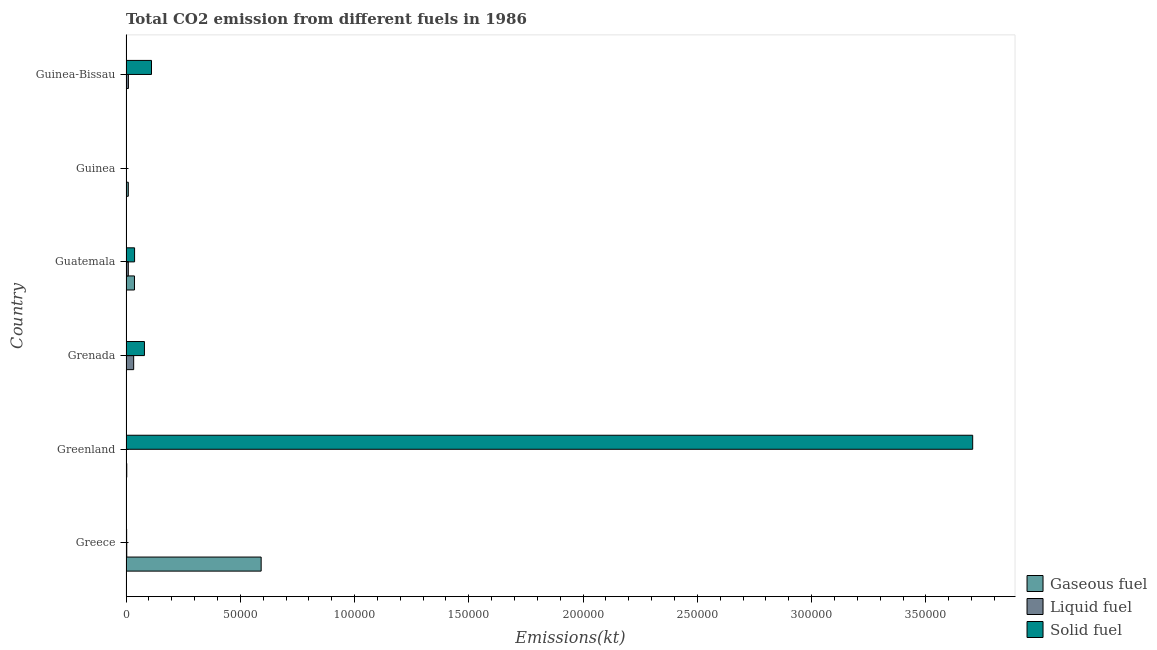How many different coloured bars are there?
Keep it short and to the point. 3. How many bars are there on the 3rd tick from the top?
Make the answer very short. 3. In how many cases, is the number of bars for a given country not equal to the number of legend labels?
Provide a succinct answer. 0. What is the amount of co2 emissions from liquid fuel in Guinea-Bissau?
Make the answer very short. 1045.1. Across all countries, what is the maximum amount of co2 emissions from liquid fuel?
Your answer should be very brief. 3351.64. Across all countries, what is the minimum amount of co2 emissions from gaseous fuel?
Your answer should be compact. 66.01. In which country was the amount of co2 emissions from solid fuel minimum?
Your answer should be compact. Guinea. What is the total amount of co2 emissions from solid fuel in the graph?
Make the answer very short. 3.94e+05. What is the difference between the amount of co2 emissions from liquid fuel in Greenland and that in Guinea-Bissau?
Ensure brevity in your answer.  -979.09. What is the difference between the amount of co2 emissions from liquid fuel in Guatemala and the amount of co2 emissions from gaseous fuel in Guinea-Bissau?
Provide a succinct answer. 814.07. What is the average amount of co2 emissions from liquid fuel per country?
Offer a terse response. 994.98. What is the difference between the amount of co2 emissions from liquid fuel and amount of co2 emissions from gaseous fuel in Greenland?
Offer a very short reply. -260.36. In how many countries, is the amount of co2 emissions from gaseous fuel greater than 60000 kt?
Offer a very short reply. 0. What is the ratio of the amount of co2 emissions from liquid fuel in Grenada to that in Guinea?
Offer a very short reply. 18.28. Is the amount of co2 emissions from gaseous fuel in Greece less than that in Guatemala?
Provide a succinct answer. No. Is the difference between the amount of co2 emissions from solid fuel in Greece and Guinea greater than the difference between the amount of co2 emissions from liquid fuel in Greece and Guinea?
Ensure brevity in your answer.  Yes. What is the difference between the highest and the second highest amount of co2 emissions from liquid fuel?
Offer a very short reply. 2306.54. What is the difference between the highest and the lowest amount of co2 emissions from liquid fuel?
Provide a succinct answer. 3285.63. In how many countries, is the amount of co2 emissions from solid fuel greater than the average amount of co2 emissions from solid fuel taken over all countries?
Your answer should be compact. 1. What does the 1st bar from the top in Greenland represents?
Provide a short and direct response. Solid fuel. What does the 3rd bar from the bottom in Guinea-Bissau represents?
Your answer should be compact. Solid fuel. How many bars are there?
Make the answer very short. 18. Are all the bars in the graph horizontal?
Offer a terse response. Yes. How many countries are there in the graph?
Give a very brief answer. 6. What is the difference between two consecutive major ticks on the X-axis?
Your answer should be compact. 5.00e+04. Where does the legend appear in the graph?
Offer a terse response. Bottom right. What is the title of the graph?
Keep it short and to the point. Total CO2 emission from different fuels in 1986. Does "Ages 60+" appear as one of the legend labels in the graph?
Provide a short and direct response. No. What is the label or title of the X-axis?
Your answer should be very brief. Emissions(kt). What is the label or title of the Y-axis?
Ensure brevity in your answer.  Country. What is the Emissions(kt) of Gaseous fuel in Greece?
Give a very brief answer. 5.91e+04. What is the Emissions(kt) of Liquid fuel in Greece?
Offer a very short reply. 326.36. What is the Emissions(kt) in Solid fuel in Greece?
Provide a succinct answer. 275.02. What is the Emissions(kt) in Gaseous fuel in Greenland?
Your answer should be very brief. 326.36. What is the Emissions(kt) of Liquid fuel in Greenland?
Offer a very short reply. 66.01. What is the Emissions(kt) in Solid fuel in Greenland?
Provide a succinct answer. 3.70e+05. What is the Emissions(kt) of Gaseous fuel in Grenada?
Make the answer very short. 66.01. What is the Emissions(kt) in Liquid fuel in Grenada?
Provide a succinct answer. 3351.64. What is the Emissions(kt) in Solid fuel in Grenada?
Make the answer very short. 8063.73. What is the Emissions(kt) in Gaseous fuel in Guatemala?
Your answer should be compact. 3700. What is the Emissions(kt) of Liquid fuel in Guatemala?
Your answer should be very brief. 997.42. What is the Emissions(kt) of Solid fuel in Guatemala?
Your response must be concise. 3747.67. What is the Emissions(kt) of Gaseous fuel in Guinea?
Provide a short and direct response. 997.42. What is the Emissions(kt) of Liquid fuel in Guinea?
Give a very brief answer. 183.35. What is the Emissions(kt) of Solid fuel in Guinea?
Make the answer very short. 3.67. What is the Emissions(kt) of Gaseous fuel in Guinea-Bissau?
Keep it short and to the point. 183.35. What is the Emissions(kt) in Liquid fuel in Guinea-Bissau?
Make the answer very short. 1045.1. What is the Emissions(kt) of Solid fuel in Guinea-Bissau?
Keep it short and to the point. 1.12e+04. Across all countries, what is the maximum Emissions(kt) in Gaseous fuel?
Provide a short and direct response. 5.91e+04. Across all countries, what is the maximum Emissions(kt) of Liquid fuel?
Your answer should be compact. 3351.64. Across all countries, what is the maximum Emissions(kt) in Solid fuel?
Offer a terse response. 3.70e+05. Across all countries, what is the minimum Emissions(kt) in Gaseous fuel?
Offer a terse response. 66.01. Across all countries, what is the minimum Emissions(kt) of Liquid fuel?
Offer a terse response. 66.01. Across all countries, what is the minimum Emissions(kt) of Solid fuel?
Your answer should be compact. 3.67. What is the total Emissions(kt) in Gaseous fuel in the graph?
Provide a succinct answer. 6.44e+04. What is the total Emissions(kt) of Liquid fuel in the graph?
Your response must be concise. 5969.88. What is the total Emissions(kt) in Solid fuel in the graph?
Ensure brevity in your answer.  3.94e+05. What is the difference between the Emissions(kt) of Gaseous fuel in Greece and that in Greenland?
Your answer should be very brief. 5.88e+04. What is the difference between the Emissions(kt) of Liquid fuel in Greece and that in Greenland?
Give a very brief answer. 260.36. What is the difference between the Emissions(kt) in Solid fuel in Greece and that in Greenland?
Give a very brief answer. -3.70e+05. What is the difference between the Emissions(kt) of Gaseous fuel in Greece and that in Grenada?
Give a very brief answer. 5.91e+04. What is the difference between the Emissions(kt) in Liquid fuel in Greece and that in Grenada?
Your answer should be compact. -3025.28. What is the difference between the Emissions(kt) of Solid fuel in Greece and that in Grenada?
Keep it short and to the point. -7788.71. What is the difference between the Emissions(kt) of Gaseous fuel in Greece and that in Guatemala?
Your answer should be compact. 5.54e+04. What is the difference between the Emissions(kt) in Liquid fuel in Greece and that in Guatemala?
Your answer should be very brief. -671.06. What is the difference between the Emissions(kt) in Solid fuel in Greece and that in Guatemala?
Your response must be concise. -3472.65. What is the difference between the Emissions(kt) of Gaseous fuel in Greece and that in Guinea?
Ensure brevity in your answer.  5.81e+04. What is the difference between the Emissions(kt) in Liquid fuel in Greece and that in Guinea?
Give a very brief answer. 143.01. What is the difference between the Emissions(kt) in Solid fuel in Greece and that in Guinea?
Ensure brevity in your answer.  271.36. What is the difference between the Emissions(kt) of Gaseous fuel in Greece and that in Guinea-Bissau?
Offer a very short reply. 5.89e+04. What is the difference between the Emissions(kt) in Liquid fuel in Greece and that in Guinea-Bissau?
Your answer should be very brief. -718.73. What is the difference between the Emissions(kt) of Solid fuel in Greece and that in Guinea-Bissau?
Your answer should be compact. -1.09e+04. What is the difference between the Emissions(kt) in Gaseous fuel in Greenland and that in Grenada?
Your answer should be compact. 260.36. What is the difference between the Emissions(kt) of Liquid fuel in Greenland and that in Grenada?
Offer a very short reply. -3285.63. What is the difference between the Emissions(kt) of Solid fuel in Greenland and that in Grenada?
Your response must be concise. 3.62e+05. What is the difference between the Emissions(kt) in Gaseous fuel in Greenland and that in Guatemala?
Your response must be concise. -3373.64. What is the difference between the Emissions(kt) of Liquid fuel in Greenland and that in Guatemala?
Provide a succinct answer. -931.42. What is the difference between the Emissions(kt) in Solid fuel in Greenland and that in Guatemala?
Your response must be concise. 3.67e+05. What is the difference between the Emissions(kt) of Gaseous fuel in Greenland and that in Guinea?
Give a very brief answer. -671.06. What is the difference between the Emissions(kt) of Liquid fuel in Greenland and that in Guinea?
Your answer should be compact. -117.34. What is the difference between the Emissions(kt) in Solid fuel in Greenland and that in Guinea?
Keep it short and to the point. 3.70e+05. What is the difference between the Emissions(kt) of Gaseous fuel in Greenland and that in Guinea-Bissau?
Your answer should be compact. 143.01. What is the difference between the Emissions(kt) of Liquid fuel in Greenland and that in Guinea-Bissau?
Your response must be concise. -979.09. What is the difference between the Emissions(kt) in Solid fuel in Greenland and that in Guinea-Bissau?
Give a very brief answer. 3.59e+05. What is the difference between the Emissions(kt) of Gaseous fuel in Grenada and that in Guatemala?
Provide a short and direct response. -3634. What is the difference between the Emissions(kt) of Liquid fuel in Grenada and that in Guatemala?
Ensure brevity in your answer.  2354.21. What is the difference between the Emissions(kt) in Solid fuel in Grenada and that in Guatemala?
Your response must be concise. 4316.06. What is the difference between the Emissions(kt) of Gaseous fuel in Grenada and that in Guinea?
Ensure brevity in your answer.  -931.42. What is the difference between the Emissions(kt) of Liquid fuel in Grenada and that in Guinea?
Provide a short and direct response. 3168.29. What is the difference between the Emissions(kt) of Solid fuel in Grenada and that in Guinea?
Provide a succinct answer. 8060.07. What is the difference between the Emissions(kt) in Gaseous fuel in Grenada and that in Guinea-Bissau?
Make the answer very short. -117.34. What is the difference between the Emissions(kt) in Liquid fuel in Grenada and that in Guinea-Bissau?
Your answer should be very brief. 2306.54. What is the difference between the Emissions(kt) of Solid fuel in Grenada and that in Guinea-Bissau?
Provide a succinct answer. -3091.28. What is the difference between the Emissions(kt) of Gaseous fuel in Guatemala and that in Guinea?
Provide a succinct answer. 2702.58. What is the difference between the Emissions(kt) of Liquid fuel in Guatemala and that in Guinea?
Give a very brief answer. 814.07. What is the difference between the Emissions(kt) of Solid fuel in Guatemala and that in Guinea?
Offer a very short reply. 3744.01. What is the difference between the Emissions(kt) in Gaseous fuel in Guatemala and that in Guinea-Bissau?
Provide a succinct answer. 3516.65. What is the difference between the Emissions(kt) in Liquid fuel in Guatemala and that in Guinea-Bissau?
Your answer should be very brief. -47.67. What is the difference between the Emissions(kt) of Solid fuel in Guatemala and that in Guinea-Bissau?
Ensure brevity in your answer.  -7407.34. What is the difference between the Emissions(kt) in Gaseous fuel in Guinea and that in Guinea-Bissau?
Provide a short and direct response. 814.07. What is the difference between the Emissions(kt) of Liquid fuel in Guinea and that in Guinea-Bissau?
Your answer should be compact. -861.75. What is the difference between the Emissions(kt) in Solid fuel in Guinea and that in Guinea-Bissau?
Give a very brief answer. -1.12e+04. What is the difference between the Emissions(kt) of Gaseous fuel in Greece and the Emissions(kt) of Liquid fuel in Greenland?
Make the answer very short. 5.91e+04. What is the difference between the Emissions(kt) of Gaseous fuel in Greece and the Emissions(kt) of Solid fuel in Greenland?
Your answer should be very brief. -3.11e+05. What is the difference between the Emissions(kt) in Liquid fuel in Greece and the Emissions(kt) in Solid fuel in Greenland?
Give a very brief answer. -3.70e+05. What is the difference between the Emissions(kt) in Gaseous fuel in Greece and the Emissions(kt) in Liquid fuel in Grenada?
Offer a very short reply. 5.58e+04. What is the difference between the Emissions(kt) of Gaseous fuel in Greece and the Emissions(kt) of Solid fuel in Grenada?
Give a very brief answer. 5.11e+04. What is the difference between the Emissions(kt) of Liquid fuel in Greece and the Emissions(kt) of Solid fuel in Grenada?
Provide a short and direct response. -7737.37. What is the difference between the Emissions(kt) in Gaseous fuel in Greece and the Emissions(kt) in Liquid fuel in Guatemala?
Offer a terse response. 5.81e+04. What is the difference between the Emissions(kt) of Gaseous fuel in Greece and the Emissions(kt) of Solid fuel in Guatemala?
Offer a very short reply. 5.54e+04. What is the difference between the Emissions(kt) in Liquid fuel in Greece and the Emissions(kt) in Solid fuel in Guatemala?
Offer a terse response. -3421.31. What is the difference between the Emissions(kt) of Gaseous fuel in Greece and the Emissions(kt) of Liquid fuel in Guinea?
Your answer should be very brief. 5.89e+04. What is the difference between the Emissions(kt) in Gaseous fuel in Greece and the Emissions(kt) in Solid fuel in Guinea?
Make the answer very short. 5.91e+04. What is the difference between the Emissions(kt) in Liquid fuel in Greece and the Emissions(kt) in Solid fuel in Guinea?
Your answer should be very brief. 322.7. What is the difference between the Emissions(kt) in Gaseous fuel in Greece and the Emissions(kt) in Liquid fuel in Guinea-Bissau?
Provide a succinct answer. 5.81e+04. What is the difference between the Emissions(kt) of Gaseous fuel in Greece and the Emissions(kt) of Solid fuel in Guinea-Bissau?
Provide a short and direct response. 4.80e+04. What is the difference between the Emissions(kt) in Liquid fuel in Greece and the Emissions(kt) in Solid fuel in Guinea-Bissau?
Your answer should be compact. -1.08e+04. What is the difference between the Emissions(kt) in Gaseous fuel in Greenland and the Emissions(kt) in Liquid fuel in Grenada?
Your response must be concise. -3025.28. What is the difference between the Emissions(kt) in Gaseous fuel in Greenland and the Emissions(kt) in Solid fuel in Grenada?
Provide a succinct answer. -7737.37. What is the difference between the Emissions(kt) in Liquid fuel in Greenland and the Emissions(kt) in Solid fuel in Grenada?
Your answer should be compact. -7997.73. What is the difference between the Emissions(kt) in Gaseous fuel in Greenland and the Emissions(kt) in Liquid fuel in Guatemala?
Your answer should be very brief. -671.06. What is the difference between the Emissions(kt) in Gaseous fuel in Greenland and the Emissions(kt) in Solid fuel in Guatemala?
Give a very brief answer. -3421.31. What is the difference between the Emissions(kt) in Liquid fuel in Greenland and the Emissions(kt) in Solid fuel in Guatemala?
Keep it short and to the point. -3681.67. What is the difference between the Emissions(kt) of Gaseous fuel in Greenland and the Emissions(kt) of Liquid fuel in Guinea?
Your response must be concise. 143.01. What is the difference between the Emissions(kt) in Gaseous fuel in Greenland and the Emissions(kt) in Solid fuel in Guinea?
Provide a succinct answer. 322.7. What is the difference between the Emissions(kt) of Liquid fuel in Greenland and the Emissions(kt) of Solid fuel in Guinea?
Your response must be concise. 62.34. What is the difference between the Emissions(kt) in Gaseous fuel in Greenland and the Emissions(kt) in Liquid fuel in Guinea-Bissau?
Your response must be concise. -718.73. What is the difference between the Emissions(kt) of Gaseous fuel in Greenland and the Emissions(kt) of Solid fuel in Guinea-Bissau?
Your answer should be very brief. -1.08e+04. What is the difference between the Emissions(kt) in Liquid fuel in Greenland and the Emissions(kt) in Solid fuel in Guinea-Bissau?
Ensure brevity in your answer.  -1.11e+04. What is the difference between the Emissions(kt) in Gaseous fuel in Grenada and the Emissions(kt) in Liquid fuel in Guatemala?
Make the answer very short. -931.42. What is the difference between the Emissions(kt) of Gaseous fuel in Grenada and the Emissions(kt) of Solid fuel in Guatemala?
Give a very brief answer. -3681.67. What is the difference between the Emissions(kt) in Liquid fuel in Grenada and the Emissions(kt) in Solid fuel in Guatemala?
Give a very brief answer. -396.04. What is the difference between the Emissions(kt) in Gaseous fuel in Grenada and the Emissions(kt) in Liquid fuel in Guinea?
Provide a short and direct response. -117.34. What is the difference between the Emissions(kt) in Gaseous fuel in Grenada and the Emissions(kt) in Solid fuel in Guinea?
Your response must be concise. 62.34. What is the difference between the Emissions(kt) in Liquid fuel in Grenada and the Emissions(kt) in Solid fuel in Guinea?
Provide a short and direct response. 3347.97. What is the difference between the Emissions(kt) of Gaseous fuel in Grenada and the Emissions(kt) of Liquid fuel in Guinea-Bissau?
Provide a succinct answer. -979.09. What is the difference between the Emissions(kt) of Gaseous fuel in Grenada and the Emissions(kt) of Solid fuel in Guinea-Bissau?
Offer a terse response. -1.11e+04. What is the difference between the Emissions(kt) in Liquid fuel in Grenada and the Emissions(kt) in Solid fuel in Guinea-Bissau?
Your response must be concise. -7803.38. What is the difference between the Emissions(kt) of Gaseous fuel in Guatemala and the Emissions(kt) of Liquid fuel in Guinea?
Your answer should be compact. 3516.65. What is the difference between the Emissions(kt) in Gaseous fuel in Guatemala and the Emissions(kt) in Solid fuel in Guinea?
Give a very brief answer. 3696.34. What is the difference between the Emissions(kt) in Liquid fuel in Guatemala and the Emissions(kt) in Solid fuel in Guinea?
Provide a short and direct response. 993.76. What is the difference between the Emissions(kt) in Gaseous fuel in Guatemala and the Emissions(kt) in Liquid fuel in Guinea-Bissau?
Keep it short and to the point. 2654.91. What is the difference between the Emissions(kt) of Gaseous fuel in Guatemala and the Emissions(kt) of Solid fuel in Guinea-Bissau?
Give a very brief answer. -7455.01. What is the difference between the Emissions(kt) in Liquid fuel in Guatemala and the Emissions(kt) in Solid fuel in Guinea-Bissau?
Your answer should be very brief. -1.02e+04. What is the difference between the Emissions(kt) in Gaseous fuel in Guinea and the Emissions(kt) in Liquid fuel in Guinea-Bissau?
Give a very brief answer. -47.67. What is the difference between the Emissions(kt) in Gaseous fuel in Guinea and the Emissions(kt) in Solid fuel in Guinea-Bissau?
Your answer should be compact. -1.02e+04. What is the difference between the Emissions(kt) in Liquid fuel in Guinea and the Emissions(kt) in Solid fuel in Guinea-Bissau?
Offer a very short reply. -1.10e+04. What is the average Emissions(kt) in Gaseous fuel per country?
Keep it short and to the point. 1.07e+04. What is the average Emissions(kt) of Liquid fuel per country?
Your answer should be very brief. 994.98. What is the average Emissions(kt) in Solid fuel per country?
Keep it short and to the point. 6.56e+04. What is the difference between the Emissions(kt) of Gaseous fuel and Emissions(kt) of Liquid fuel in Greece?
Provide a succinct answer. 5.88e+04. What is the difference between the Emissions(kt) of Gaseous fuel and Emissions(kt) of Solid fuel in Greece?
Give a very brief answer. 5.89e+04. What is the difference between the Emissions(kt) in Liquid fuel and Emissions(kt) in Solid fuel in Greece?
Offer a terse response. 51.34. What is the difference between the Emissions(kt) in Gaseous fuel and Emissions(kt) in Liquid fuel in Greenland?
Make the answer very short. 260.36. What is the difference between the Emissions(kt) of Gaseous fuel and Emissions(kt) of Solid fuel in Greenland?
Offer a terse response. -3.70e+05. What is the difference between the Emissions(kt) of Liquid fuel and Emissions(kt) of Solid fuel in Greenland?
Keep it short and to the point. -3.70e+05. What is the difference between the Emissions(kt) in Gaseous fuel and Emissions(kt) in Liquid fuel in Grenada?
Offer a terse response. -3285.63. What is the difference between the Emissions(kt) of Gaseous fuel and Emissions(kt) of Solid fuel in Grenada?
Provide a short and direct response. -7997.73. What is the difference between the Emissions(kt) in Liquid fuel and Emissions(kt) in Solid fuel in Grenada?
Provide a succinct answer. -4712.1. What is the difference between the Emissions(kt) in Gaseous fuel and Emissions(kt) in Liquid fuel in Guatemala?
Provide a succinct answer. 2702.58. What is the difference between the Emissions(kt) of Gaseous fuel and Emissions(kt) of Solid fuel in Guatemala?
Your response must be concise. -47.67. What is the difference between the Emissions(kt) in Liquid fuel and Emissions(kt) in Solid fuel in Guatemala?
Provide a succinct answer. -2750.25. What is the difference between the Emissions(kt) in Gaseous fuel and Emissions(kt) in Liquid fuel in Guinea?
Give a very brief answer. 814.07. What is the difference between the Emissions(kt) of Gaseous fuel and Emissions(kt) of Solid fuel in Guinea?
Keep it short and to the point. 993.76. What is the difference between the Emissions(kt) of Liquid fuel and Emissions(kt) of Solid fuel in Guinea?
Offer a very short reply. 179.68. What is the difference between the Emissions(kt) of Gaseous fuel and Emissions(kt) of Liquid fuel in Guinea-Bissau?
Your answer should be compact. -861.75. What is the difference between the Emissions(kt) in Gaseous fuel and Emissions(kt) in Solid fuel in Guinea-Bissau?
Offer a terse response. -1.10e+04. What is the difference between the Emissions(kt) of Liquid fuel and Emissions(kt) of Solid fuel in Guinea-Bissau?
Make the answer very short. -1.01e+04. What is the ratio of the Emissions(kt) in Gaseous fuel in Greece to that in Greenland?
Ensure brevity in your answer.  181.18. What is the ratio of the Emissions(kt) in Liquid fuel in Greece to that in Greenland?
Provide a short and direct response. 4.94. What is the ratio of the Emissions(kt) of Solid fuel in Greece to that in Greenland?
Your answer should be very brief. 0. What is the ratio of the Emissions(kt) of Gaseous fuel in Greece to that in Grenada?
Your answer should be very brief. 895.83. What is the ratio of the Emissions(kt) of Liquid fuel in Greece to that in Grenada?
Provide a short and direct response. 0.1. What is the ratio of the Emissions(kt) of Solid fuel in Greece to that in Grenada?
Provide a short and direct response. 0.03. What is the ratio of the Emissions(kt) in Gaseous fuel in Greece to that in Guatemala?
Your answer should be compact. 15.98. What is the ratio of the Emissions(kt) in Liquid fuel in Greece to that in Guatemala?
Your answer should be compact. 0.33. What is the ratio of the Emissions(kt) in Solid fuel in Greece to that in Guatemala?
Ensure brevity in your answer.  0.07. What is the ratio of the Emissions(kt) in Gaseous fuel in Greece to that in Guinea?
Make the answer very short. 59.28. What is the ratio of the Emissions(kt) of Liquid fuel in Greece to that in Guinea?
Your answer should be very brief. 1.78. What is the ratio of the Emissions(kt) of Gaseous fuel in Greece to that in Guinea-Bissau?
Give a very brief answer. 322.5. What is the ratio of the Emissions(kt) of Liquid fuel in Greece to that in Guinea-Bissau?
Your answer should be very brief. 0.31. What is the ratio of the Emissions(kt) in Solid fuel in Greece to that in Guinea-Bissau?
Your response must be concise. 0.02. What is the ratio of the Emissions(kt) in Gaseous fuel in Greenland to that in Grenada?
Provide a succinct answer. 4.94. What is the ratio of the Emissions(kt) in Liquid fuel in Greenland to that in Grenada?
Give a very brief answer. 0.02. What is the ratio of the Emissions(kt) of Solid fuel in Greenland to that in Grenada?
Make the answer very short. 45.94. What is the ratio of the Emissions(kt) of Gaseous fuel in Greenland to that in Guatemala?
Offer a very short reply. 0.09. What is the ratio of the Emissions(kt) in Liquid fuel in Greenland to that in Guatemala?
Keep it short and to the point. 0.07. What is the ratio of the Emissions(kt) in Solid fuel in Greenland to that in Guatemala?
Make the answer very short. 98.85. What is the ratio of the Emissions(kt) of Gaseous fuel in Greenland to that in Guinea?
Make the answer very short. 0.33. What is the ratio of the Emissions(kt) of Liquid fuel in Greenland to that in Guinea?
Offer a terse response. 0.36. What is the ratio of the Emissions(kt) of Solid fuel in Greenland to that in Guinea?
Your answer should be very brief. 1.01e+05. What is the ratio of the Emissions(kt) in Gaseous fuel in Greenland to that in Guinea-Bissau?
Your response must be concise. 1.78. What is the ratio of the Emissions(kt) in Liquid fuel in Greenland to that in Guinea-Bissau?
Provide a succinct answer. 0.06. What is the ratio of the Emissions(kt) in Solid fuel in Greenland to that in Guinea-Bissau?
Your answer should be very brief. 33.21. What is the ratio of the Emissions(kt) in Gaseous fuel in Grenada to that in Guatemala?
Ensure brevity in your answer.  0.02. What is the ratio of the Emissions(kt) in Liquid fuel in Grenada to that in Guatemala?
Keep it short and to the point. 3.36. What is the ratio of the Emissions(kt) of Solid fuel in Grenada to that in Guatemala?
Provide a succinct answer. 2.15. What is the ratio of the Emissions(kt) in Gaseous fuel in Grenada to that in Guinea?
Provide a succinct answer. 0.07. What is the ratio of the Emissions(kt) of Liquid fuel in Grenada to that in Guinea?
Provide a succinct answer. 18.28. What is the ratio of the Emissions(kt) in Solid fuel in Grenada to that in Guinea?
Provide a succinct answer. 2199. What is the ratio of the Emissions(kt) of Gaseous fuel in Grenada to that in Guinea-Bissau?
Offer a terse response. 0.36. What is the ratio of the Emissions(kt) of Liquid fuel in Grenada to that in Guinea-Bissau?
Your answer should be compact. 3.21. What is the ratio of the Emissions(kt) in Solid fuel in Grenada to that in Guinea-Bissau?
Give a very brief answer. 0.72. What is the ratio of the Emissions(kt) in Gaseous fuel in Guatemala to that in Guinea?
Make the answer very short. 3.71. What is the ratio of the Emissions(kt) in Liquid fuel in Guatemala to that in Guinea?
Offer a terse response. 5.44. What is the ratio of the Emissions(kt) of Solid fuel in Guatemala to that in Guinea?
Make the answer very short. 1022. What is the ratio of the Emissions(kt) of Gaseous fuel in Guatemala to that in Guinea-Bissau?
Give a very brief answer. 20.18. What is the ratio of the Emissions(kt) of Liquid fuel in Guatemala to that in Guinea-Bissau?
Give a very brief answer. 0.95. What is the ratio of the Emissions(kt) of Solid fuel in Guatemala to that in Guinea-Bissau?
Your answer should be compact. 0.34. What is the ratio of the Emissions(kt) in Gaseous fuel in Guinea to that in Guinea-Bissau?
Provide a succinct answer. 5.44. What is the ratio of the Emissions(kt) of Liquid fuel in Guinea to that in Guinea-Bissau?
Your response must be concise. 0.18. What is the difference between the highest and the second highest Emissions(kt) of Gaseous fuel?
Your answer should be compact. 5.54e+04. What is the difference between the highest and the second highest Emissions(kt) of Liquid fuel?
Your answer should be very brief. 2306.54. What is the difference between the highest and the second highest Emissions(kt) in Solid fuel?
Make the answer very short. 3.59e+05. What is the difference between the highest and the lowest Emissions(kt) in Gaseous fuel?
Provide a succinct answer. 5.91e+04. What is the difference between the highest and the lowest Emissions(kt) in Liquid fuel?
Offer a terse response. 3285.63. What is the difference between the highest and the lowest Emissions(kt) of Solid fuel?
Make the answer very short. 3.70e+05. 